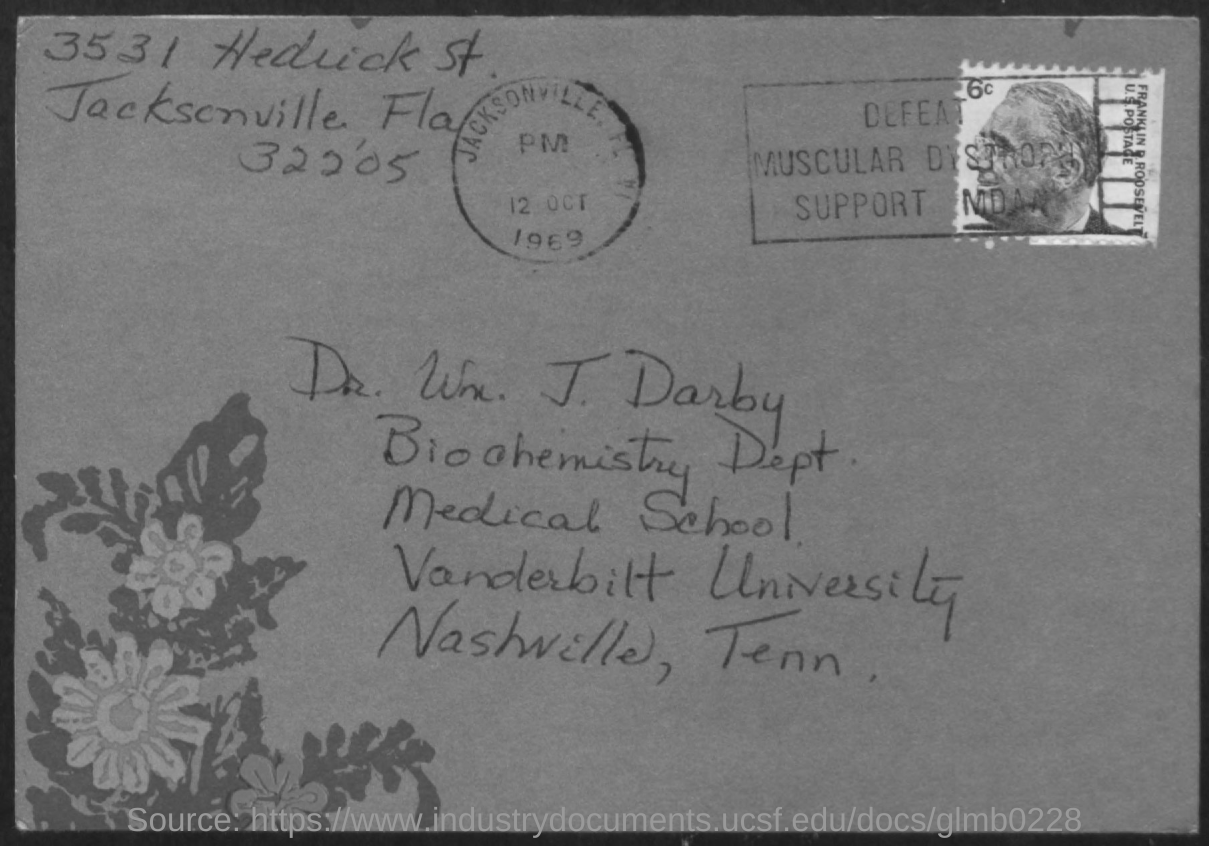To whom is the letter addressed?
Give a very brief answer. Dr. Wx. J. Darby. Which department is mentioned?
Offer a very short reply. Biochemistry dept. Which university is mentioned?
Make the answer very short. Vanderbilt University. 